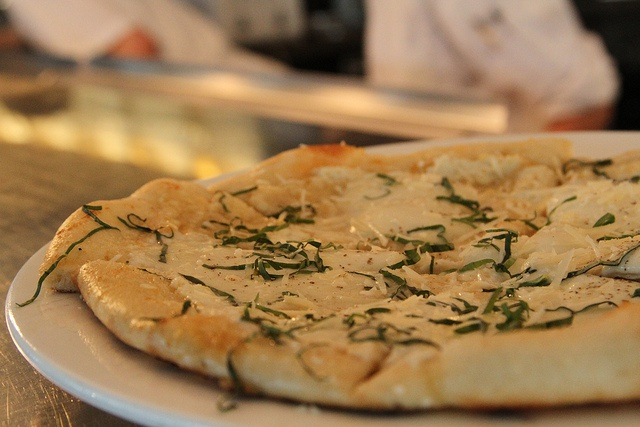Describe the objects in this image and their specific colors. I can see pizza in gray, tan, and olive tones, people in gray and tan tones, dining table in gray, olive, brown, and tan tones, and people in gray and tan tones in this image. 